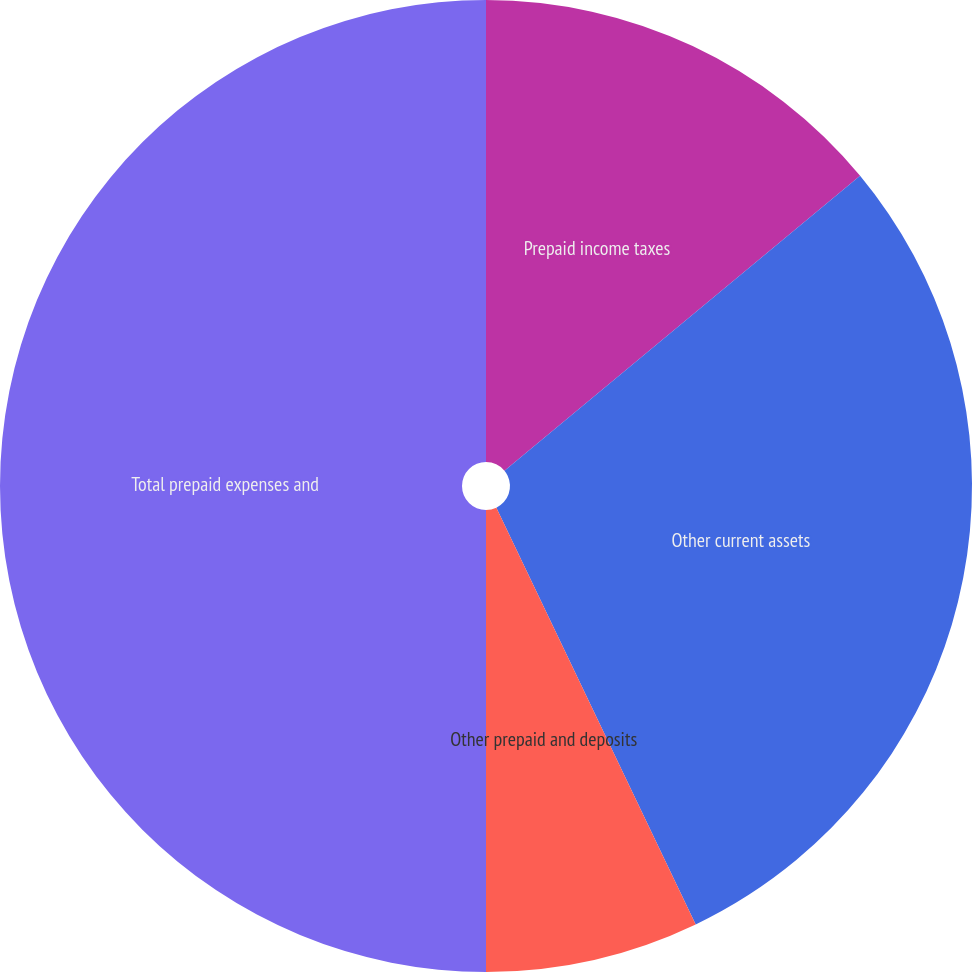Convert chart to OTSL. <chart><loc_0><loc_0><loc_500><loc_500><pie_chart><fcel>Prepaid income taxes<fcel>Other current assets<fcel>Other prepaid and deposits<fcel>Total prepaid expenses and<nl><fcel>13.98%<fcel>28.92%<fcel>7.1%<fcel>50.0%<nl></chart> 